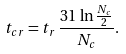<formula> <loc_0><loc_0><loc_500><loc_500>t _ { c r } = t _ { r } \, \frac { 3 1 \, \ln \frac { N _ { c } } { 2 } } { N _ { c } } .</formula> 